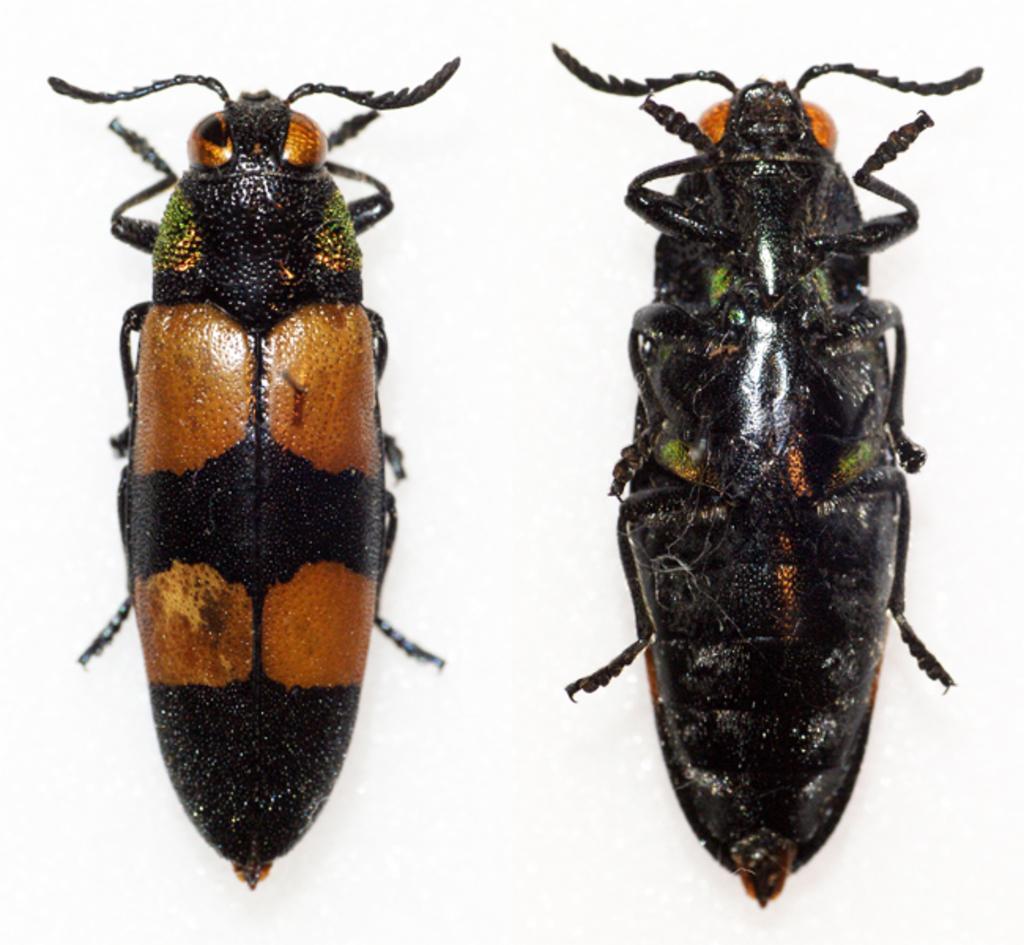How would you summarize this image in a sentence or two? In this image, we can see there are two insects having legs on a surface. And the background is white in color. 